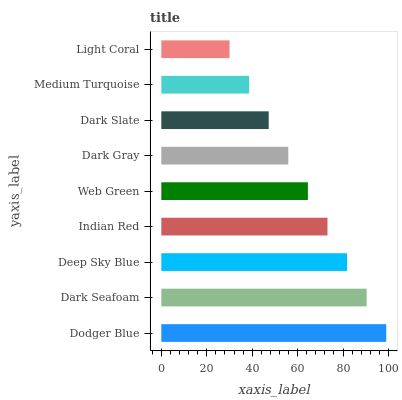Is Light Coral the minimum?
Answer yes or no. Yes. Is Dodger Blue the maximum?
Answer yes or no. Yes. Is Dark Seafoam the minimum?
Answer yes or no. No. Is Dark Seafoam the maximum?
Answer yes or no. No. Is Dodger Blue greater than Dark Seafoam?
Answer yes or no. Yes. Is Dark Seafoam less than Dodger Blue?
Answer yes or no. Yes. Is Dark Seafoam greater than Dodger Blue?
Answer yes or no. No. Is Dodger Blue less than Dark Seafoam?
Answer yes or no. No. Is Web Green the high median?
Answer yes or no. Yes. Is Web Green the low median?
Answer yes or no. Yes. Is Dark Gray the high median?
Answer yes or no. No. Is Dodger Blue the low median?
Answer yes or no. No. 